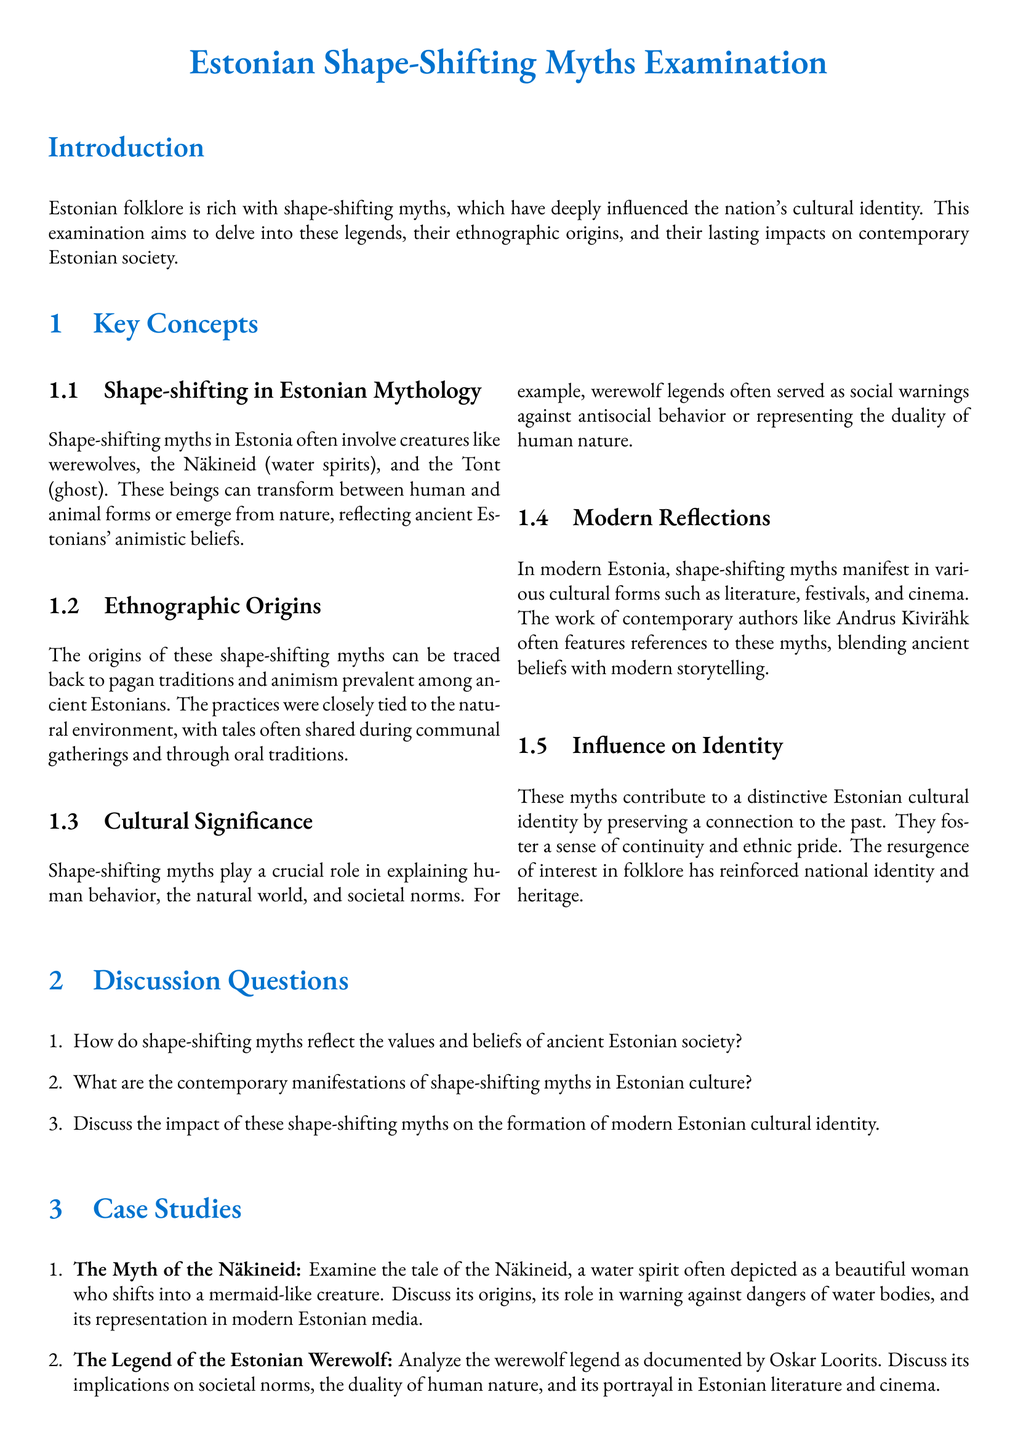What is the title of the examination? The title indicated in the document identifies the focus of the examination on Estonian shape-shifting myths.
Answer: Estonian Shape-Shifting Myths Examination Which creature is NOT mentioned as a shape-shifter in Estonian mythology? The document lists specific beings associated with shape-shifting myths and identifies those included in the text.
Answer: Tont What is the primary source of ethnographic origins for these myths? The document states that the origins of shape-shifting myths can be traced to specific cultural beliefs and traditions.
Answer: Pagan traditions What role do shape-shifting myths serve in society? The myths are discussed in terms of their cultural significance and how they reflect human behavior and societal norms.
Answer: Social warnings Who is a contemporary author mentioned in the document that references these myths? The document lists modern figures influenced by folklore in their work.
Answer: Andrus Kivirähk Which water spirit is specifically analyzed in the case studies? The document provides case studies on specific shape-shifting myths, identifying unique characters.
Answer: Näkineid What is a key theme represented in the legend of the Estonian werewolf? The document highlights explicit themes in the werewolf legend that are significant to societal norms.
Answer: Duality of human nature How are the legends primarily preserved and shared in ancient times? The document describes how these myths were communicated within communities during a specific historical context.
Answer: Oral traditions 